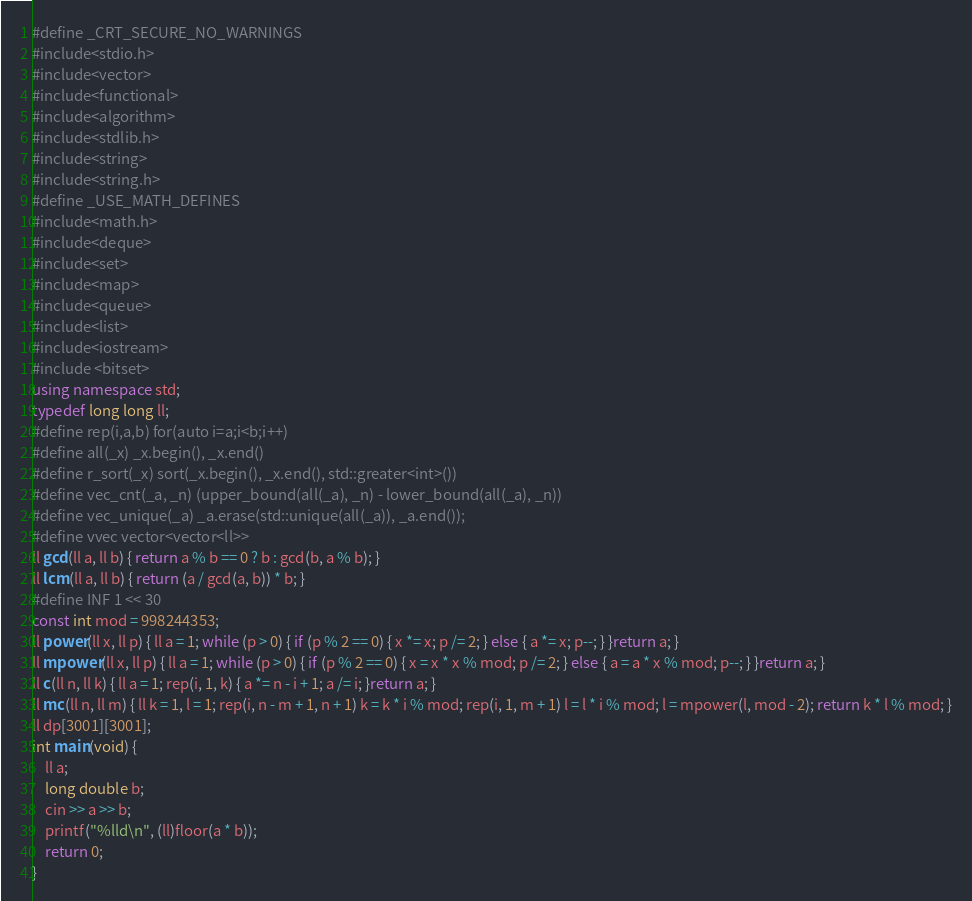Convert code to text. <code><loc_0><loc_0><loc_500><loc_500><_C++_>#define _CRT_SECURE_NO_WARNINGS
#include<stdio.h>
#include<vector>
#include<functional>
#include<algorithm>
#include<stdlib.h>
#include<string>
#include<string.h>
#define _USE_MATH_DEFINES
#include<math.h>
#include<deque>
#include<set>
#include<map>
#include<queue>
#include<list>
#include<iostream>
#include <bitset>
using namespace std;
typedef long long ll;
#define rep(i,a,b) for(auto i=a;i<b;i++)
#define all(_x) _x.begin(), _x.end()
#define r_sort(_x) sort(_x.begin(), _x.end(), std::greater<int>())
#define vec_cnt(_a, _n) (upper_bound(all(_a), _n) - lower_bound(all(_a), _n))
#define vec_unique(_a) _a.erase(std::unique(all(_a)), _a.end());
#define vvec vector<vector<ll>>
ll gcd(ll a, ll b) { return a % b == 0 ? b : gcd(b, a % b); }
ll lcm(ll a, ll b) { return (a / gcd(a, b)) * b; }
#define INF 1 << 30
const int mod = 998244353;
ll power(ll x, ll p) { ll a = 1; while (p > 0) { if (p % 2 == 0) { x *= x; p /= 2; } else { a *= x; p--; } }return a; }
ll mpower(ll x, ll p) { ll a = 1; while (p > 0) { if (p % 2 == 0) { x = x * x % mod; p /= 2; } else { a = a * x % mod; p--; } }return a; }
ll c(ll n, ll k) { ll a = 1; rep(i, 1, k) { a *= n - i + 1; a /= i; }return a; }
ll mc(ll n, ll m) { ll k = 1, l = 1; rep(i, n - m + 1, n + 1) k = k * i % mod; rep(i, 1, m + 1) l = l * i % mod; l = mpower(l, mod - 2); return k * l % mod; }
ll dp[3001][3001];
int main(void) {
	ll a;
	long double b;
	cin >> a >> b;
	printf("%lld\n", (ll)floor(a * b));
	return 0;
}
</code> 